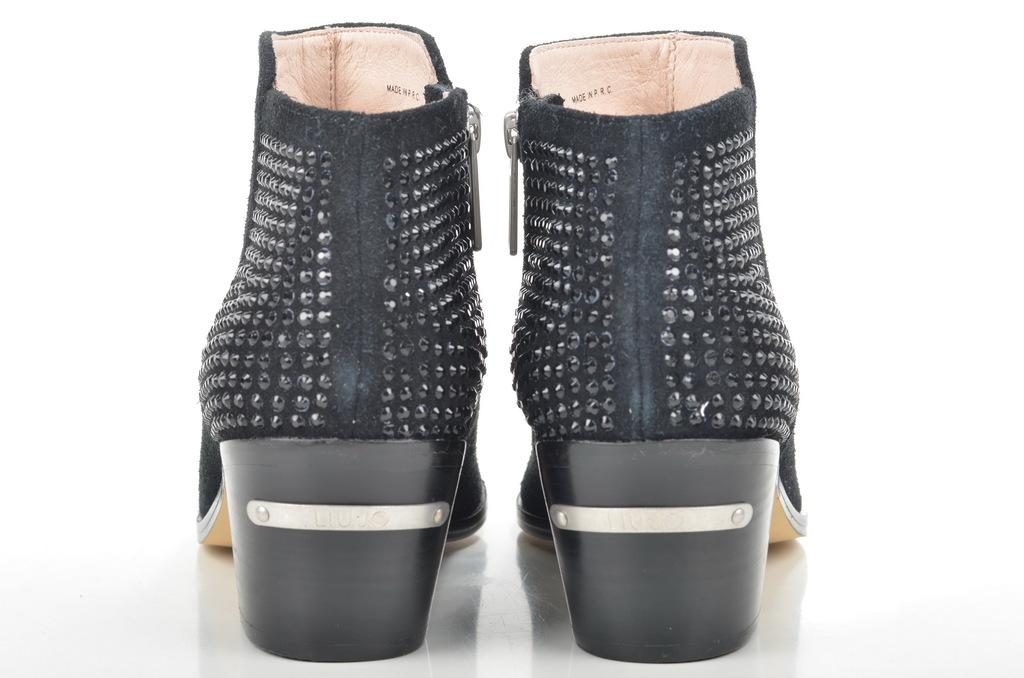What type of footwear is visible in the image? There are two black color shoes in the image. Can you describe the shoes in more detail? Unfortunately, the image only provides information about the color of the shoes, which is black. Are there any other items or objects visible in the image? No, the only item mentioned in the facts is the pair of black shoes. What type of winter clothing is visible in the image? There is no winter clothing visible in the image; only two black color shoes are mentioned. Can you tell me where the elbow of the person wearing the shoes is located in the image? There is no person visible in the image, so it is impossible to determine the location of their elbow. 